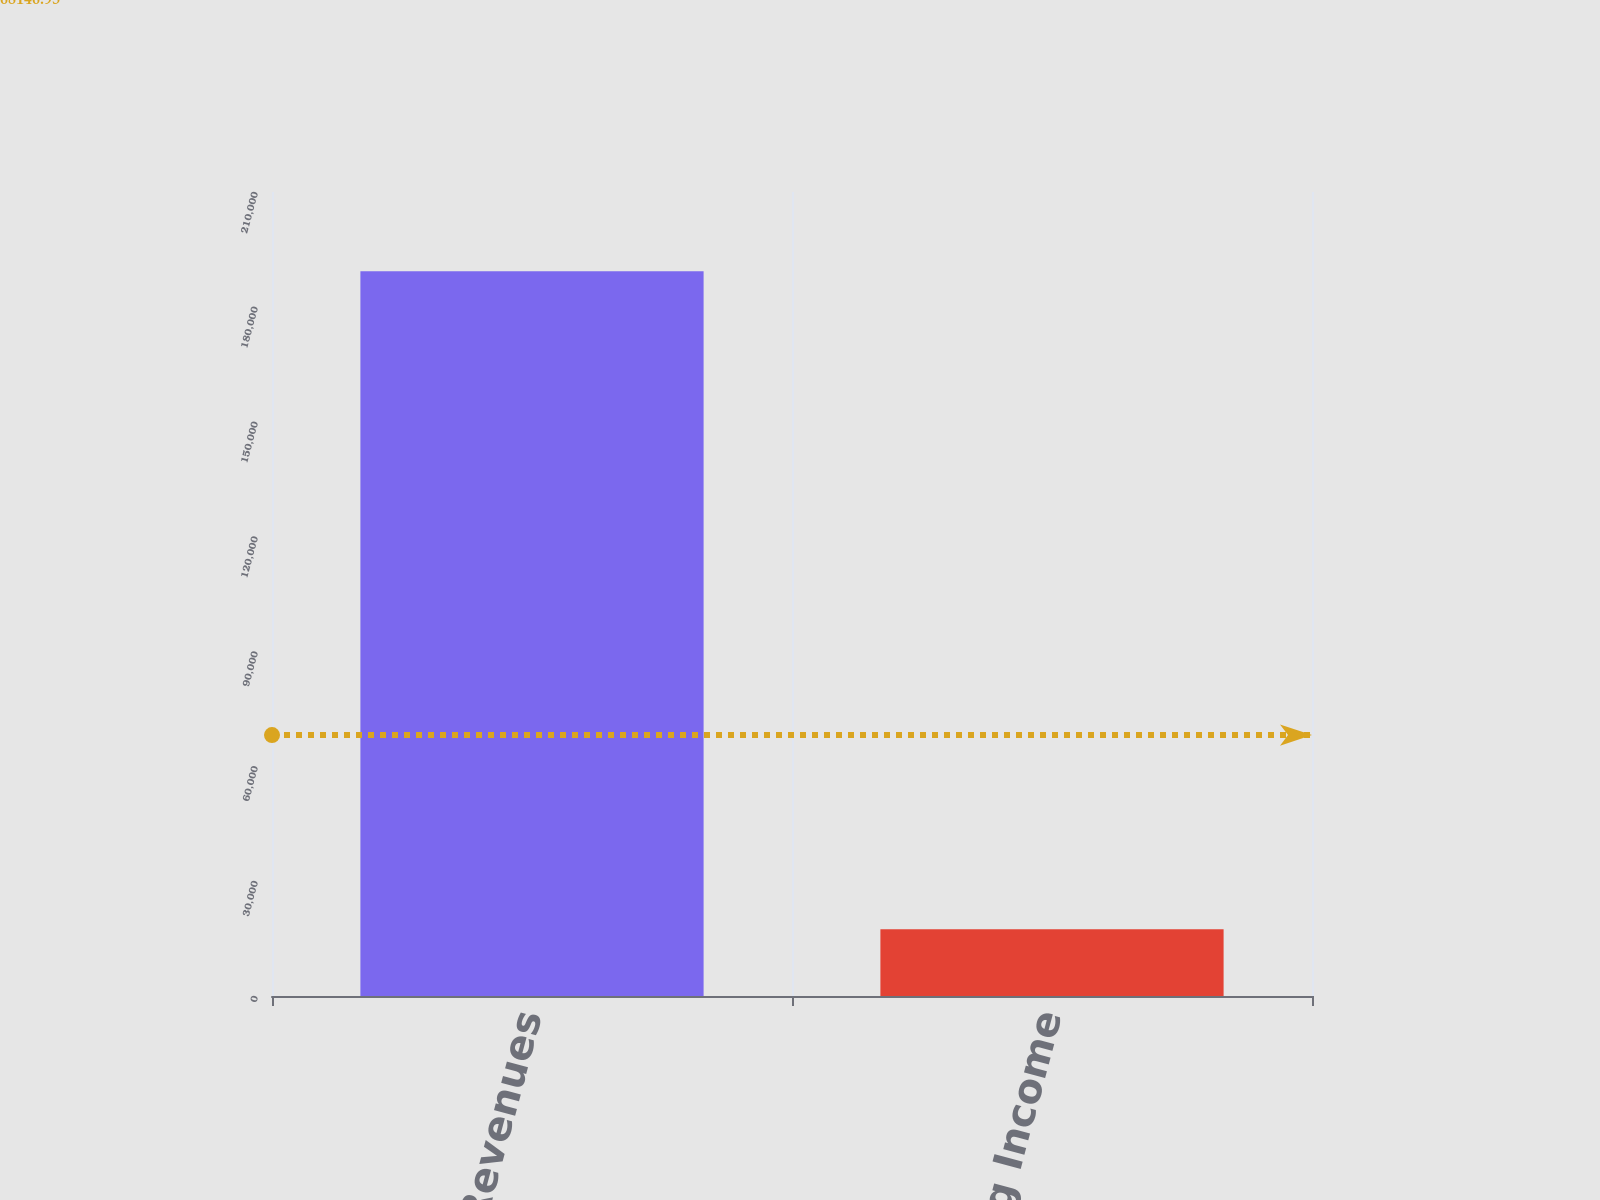Convert chart to OTSL. <chart><loc_0><loc_0><loc_500><loc_500><bar_chart><fcel>Total Revenues<fcel>Operating Income<nl><fcel>189313<fcel>17460<nl></chart> 